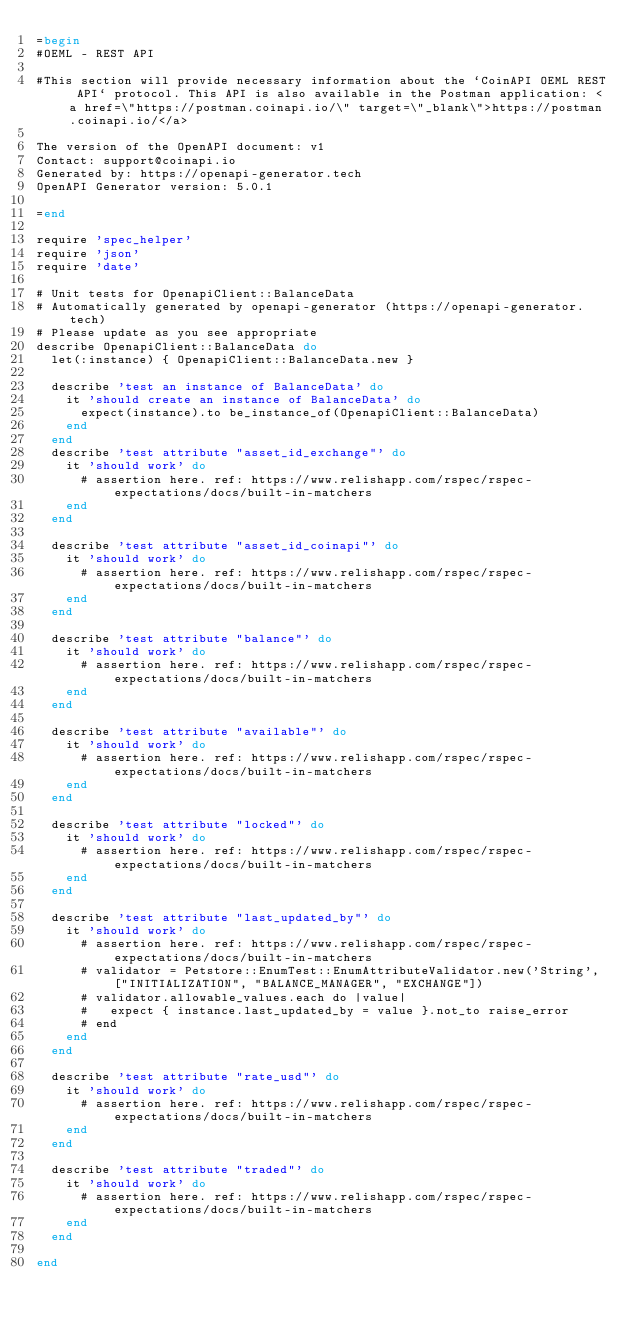<code> <loc_0><loc_0><loc_500><loc_500><_Ruby_>=begin
#OEML - REST API

#This section will provide necessary information about the `CoinAPI OEML REST API` protocol. This API is also available in the Postman application: <a href=\"https://postman.coinapi.io/\" target=\"_blank\">https://postman.coinapi.io/</a>       

The version of the OpenAPI document: v1
Contact: support@coinapi.io
Generated by: https://openapi-generator.tech
OpenAPI Generator version: 5.0.1

=end

require 'spec_helper'
require 'json'
require 'date'

# Unit tests for OpenapiClient::BalanceData
# Automatically generated by openapi-generator (https://openapi-generator.tech)
# Please update as you see appropriate
describe OpenapiClient::BalanceData do
  let(:instance) { OpenapiClient::BalanceData.new }

  describe 'test an instance of BalanceData' do
    it 'should create an instance of BalanceData' do
      expect(instance).to be_instance_of(OpenapiClient::BalanceData)
    end
  end
  describe 'test attribute "asset_id_exchange"' do
    it 'should work' do
      # assertion here. ref: https://www.relishapp.com/rspec/rspec-expectations/docs/built-in-matchers
    end
  end

  describe 'test attribute "asset_id_coinapi"' do
    it 'should work' do
      # assertion here. ref: https://www.relishapp.com/rspec/rspec-expectations/docs/built-in-matchers
    end
  end

  describe 'test attribute "balance"' do
    it 'should work' do
      # assertion here. ref: https://www.relishapp.com/rspec/rspec-expectations/docs/built-in-matchers
    end
  end

  describe 'test attribute "available"' do
    it 'should work' do
      # assertion here. ref: https://www.relishapp.com/rspec/rspec-expectations/docs/built-in-matchers
    end
  end

  describe 'test attribute "locked"' do
    it 'should work' do
      # assertion here. ref: https://www.relishapp.com/rspec/rspec-expectations/docs/built-in-matchers
    end
  end

  describe 'test attribute "last_updated_by"' do
    it 'should work' do
      # assertion here. ref: https://www.relishapp.com/rspec/rspec-expectations/docs/built-in-matchers
      # validator = Petstore::EnumTest::EnumAttributeValidator.new('String', ["INITIALIZATION", "BALANCE_MANAGER", "EXCHANGE"])
      # validator.allowable_values.each do |value|
      #   expect { instance.last_updated_by = value }.not_to raise_error
      # end
    end
  end

  describe 'test attribute "rate_usd"' do
    it 'should work' do
      # assertion here. ref: https://www.relishapp.com/rspec/rspec-expectations/docs/built-in-matchers
    end
  end

  describe 'test attribute "traded"' do
    it 'should work' do
      # assertion here. ref: https://www.relishapp.com/rspec/rspec-expectations/docs/built-in-matchers
    end
  end

end
</code> 